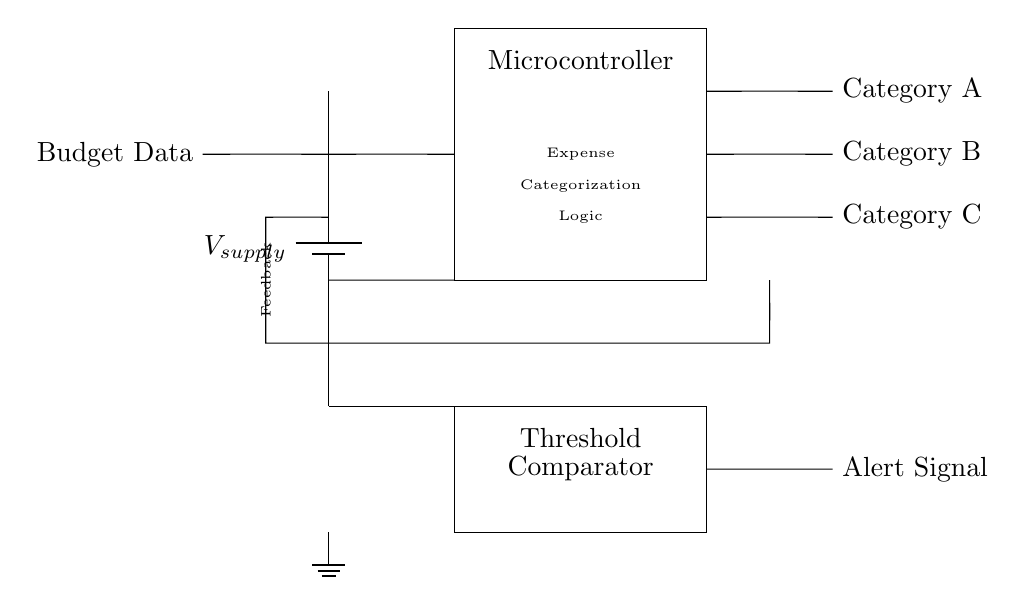What is the main component of this circuit? The main component is the Microcontroller, which is tasked with expense categorization logic based on the input budget data.
Answer: Microcontroller What is the purpose of the feedback loop? The feedback loop connects the output of the categorization logic back to the input, allowing the system to adjust or correct based on previous outputs or conditions, making the process adaptive.
Answer: Feedback How many output categories are there? There are three output categories labeled as Category A, Category B, and Category C, indicating that the system can classify expense data into three different segments.
Answer: Three What type of signal does the Threshold Comparator output? The Threshold Comparator outputs an Alert Signal when the conditions it monitors are met, functioning as a response mechanism to set threshold values to trigger alerts.
Answer: Alert Signal What is the function of Budget Data in the circuit? Budget Data serves as the input signal that the Microcontroller processes to categorize expenses according to predefined criteria based on conditional logic.
Answer: Input signal What connects the Budget Data to the Microcontroller? A short connection wire connects the Budget Data to the Microcontroller, ensuring that the budget information is transmitted for processing.
Answer: Short connection What is the significance of the battery in this circuit? The battery supplies the voltage necessary for the entire circuit operation, powering all components including the Microcontroller and Comparator to function correctly.
Answer: Voltage supply 